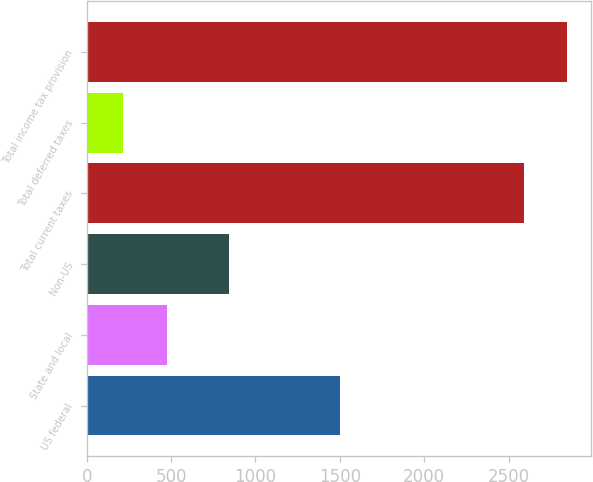<chart> <loc_0><loc_0><loc_500><loc_500><bar_chart><fcel>US federal<fcel>State and local<fcel>Non-US<fcel>Total current taxes<fcel>Total deferred taxes<fcel>Total income tax provision<nl><fcel>1504<fcel>473<fcel>843<fcel>2590<fcel>214<fcel>2849<nl></chart> 